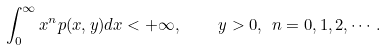Convert formula to latex. <formula><loc_0><loc_0><loc_500><loc_500>\int _ { 0 } ^ { \infty } x ^ { n } p ( x , y ) d x < + \infty , \quad y > 0 , \ n = 0 , 1 , 2 , \cdots .</formula> 